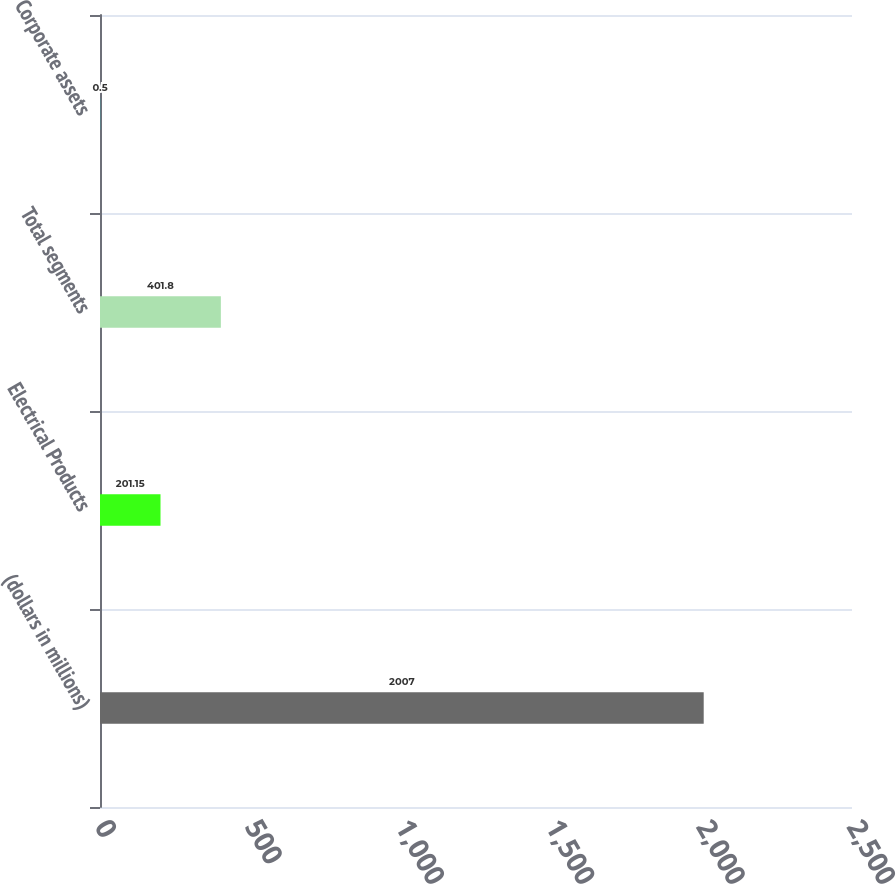<chart> <loc_0><loc_0><loc_500><loc_500><bar_chart><fcel>(dollars in millions)<fcel>Electrical Products<fcel>Total segments<fcel>Corporate assets<nl><fcel>2007<fcel>201.15<fcel>401.8<fcel>0.5<nl></chart> 